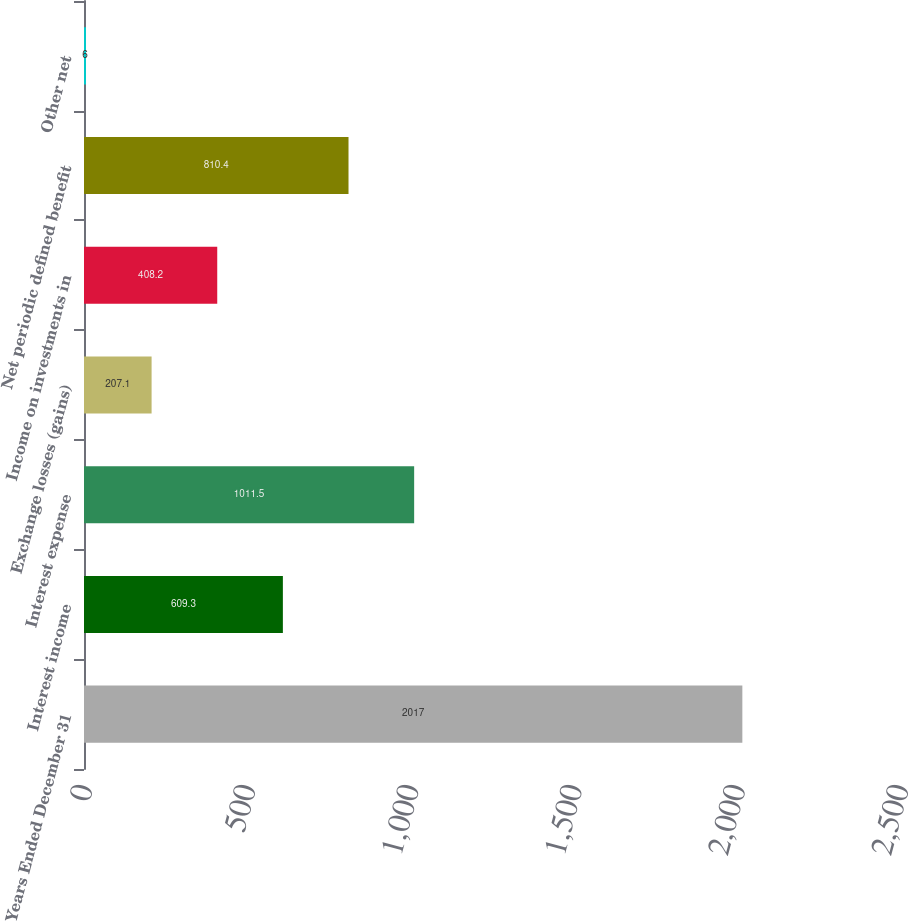Convert chart to OTSL. <chart><loc_0><loc_0><loc_500><loc_500><bar_chart><fcel>Years Ended December 31<fcel>Interest income<fcel>Interest expense<fcel>Exchange losses (gains)<fcel>Income on investments in<fcel>Net periodic defined benefit<fcel>Other net<nl><fcel>2017<fcel>609.3<fcel>1011.5<fcel>207.1<fcel>408.2<fcel>810.4<fcel>6<nl></chart> 